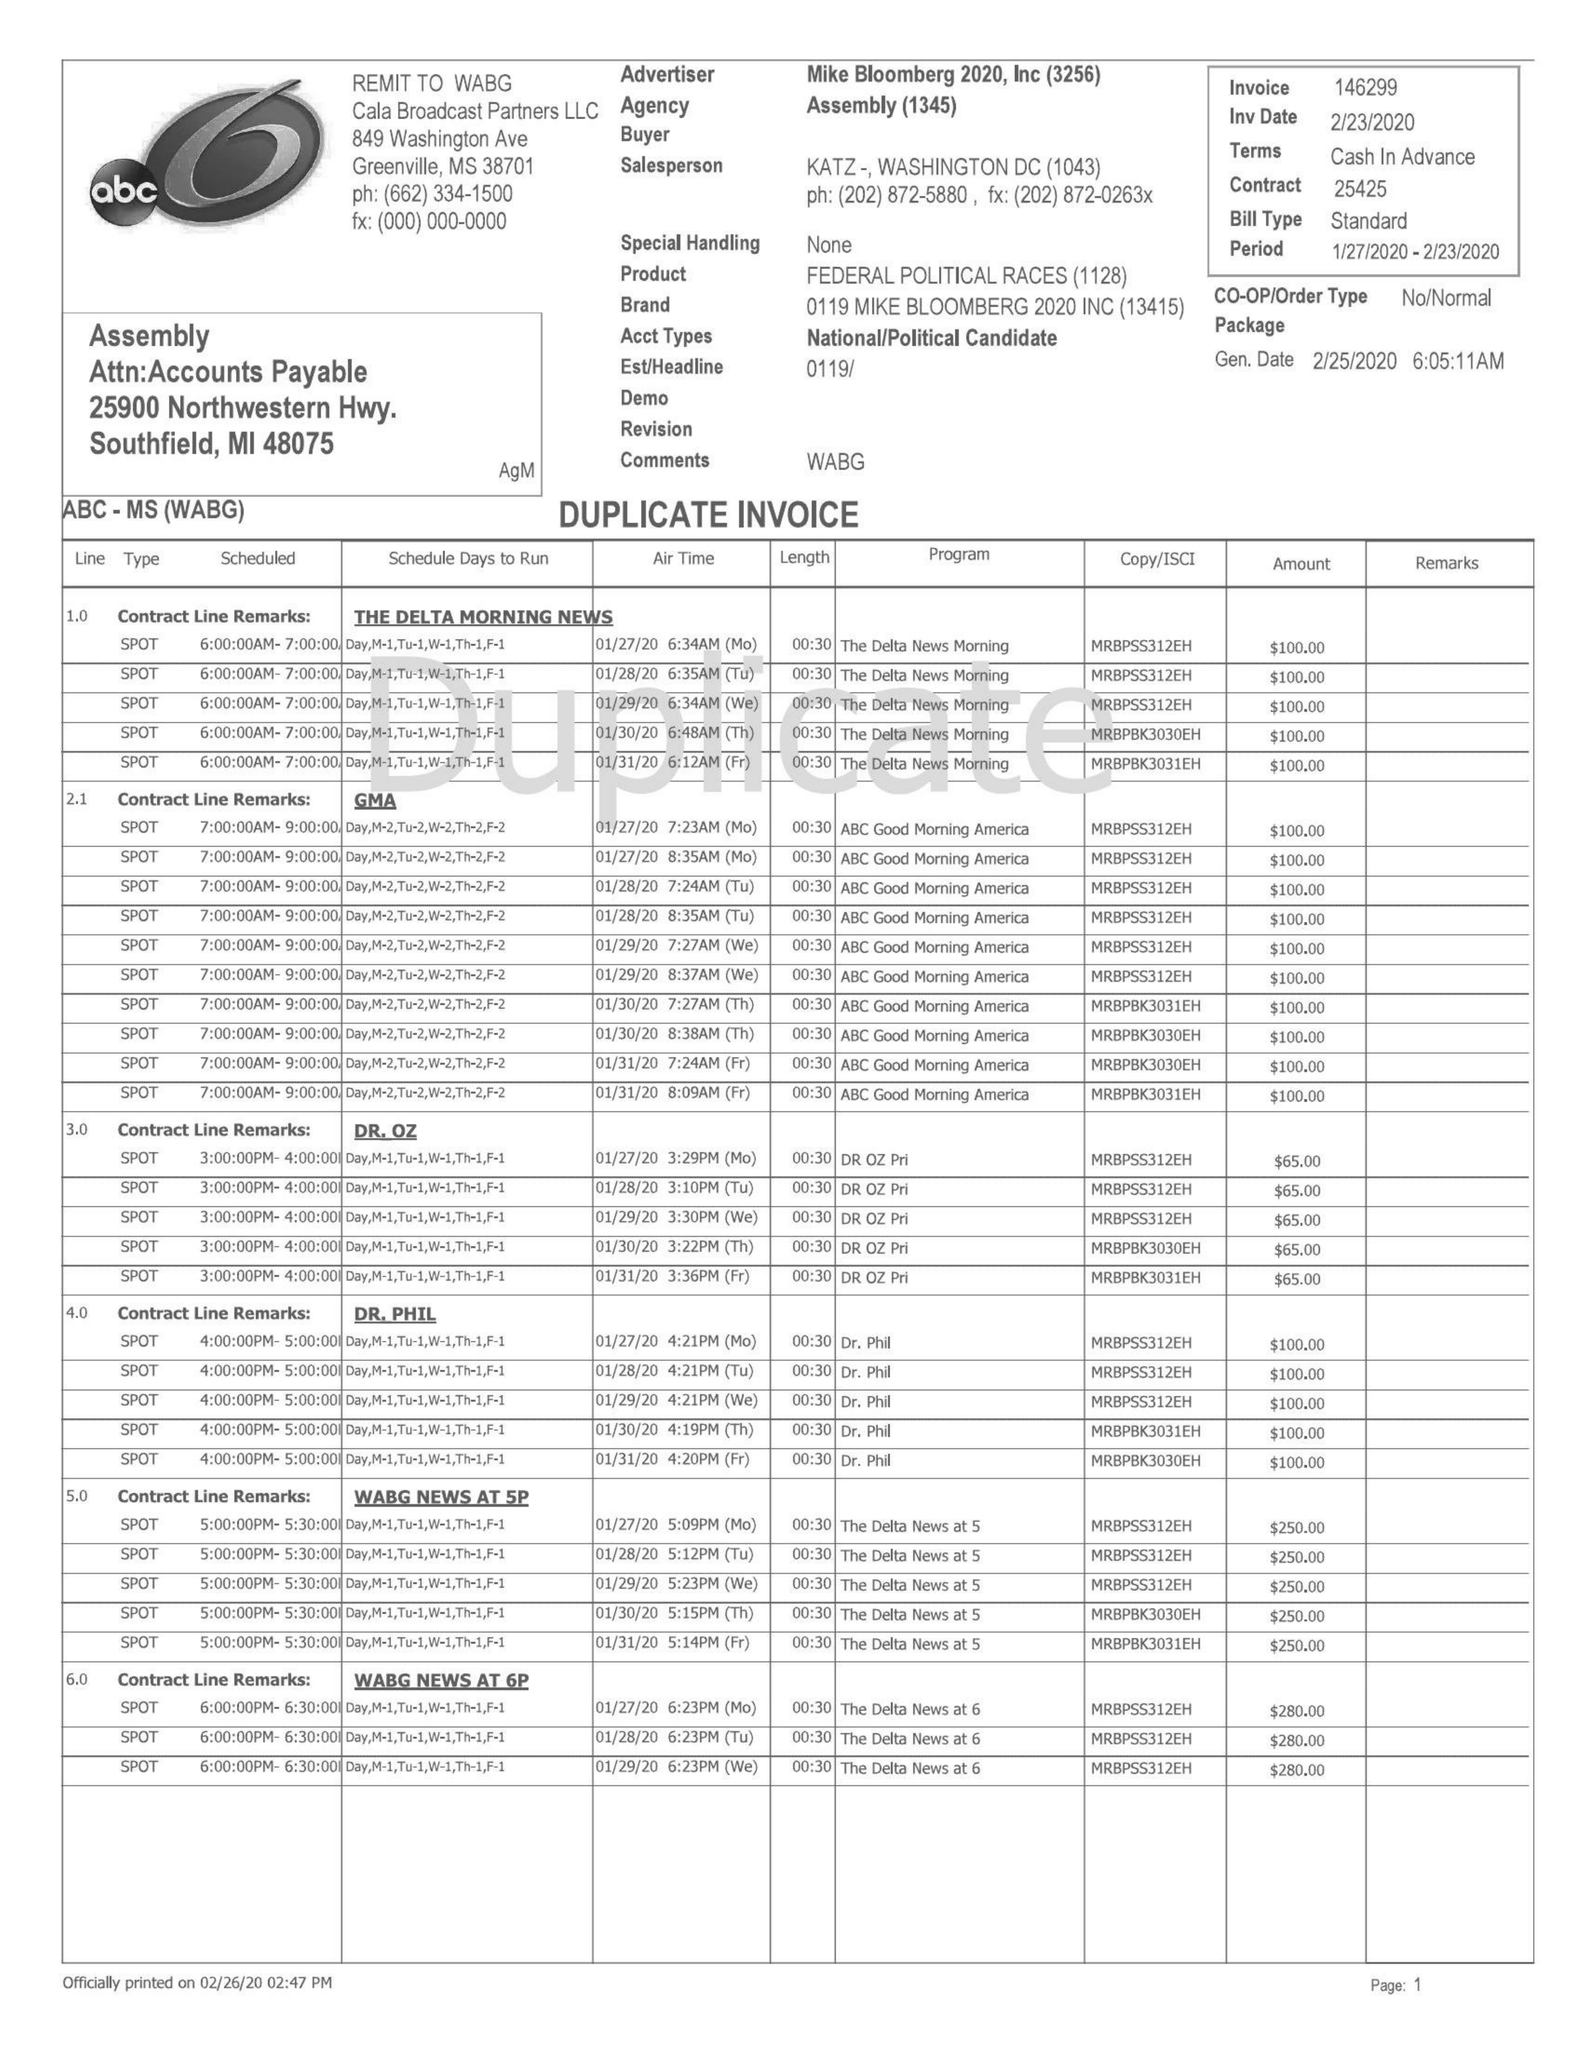What is the value for the flight_from?
Answer the question using a single word or phrase. 01/27/20 